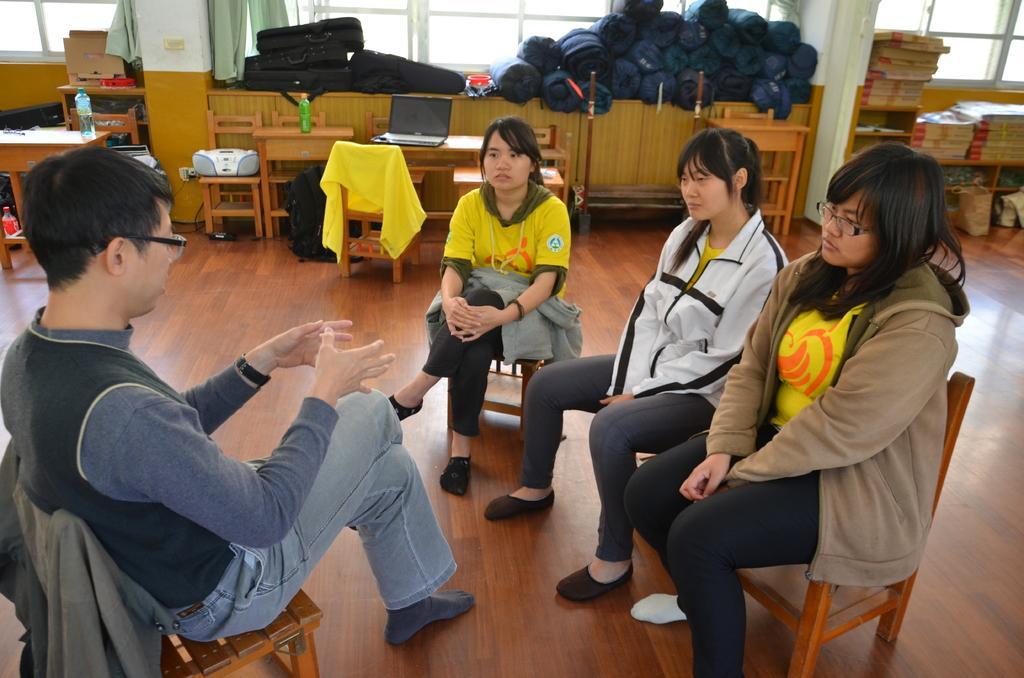In one or two sentences, can you explain what this image depicts? In this picture we can see three woman and one men sitting on chairs where man is talking and in background we can see bottle, laptop, tape recorder on table and chairs, pillar, window, sheets. 